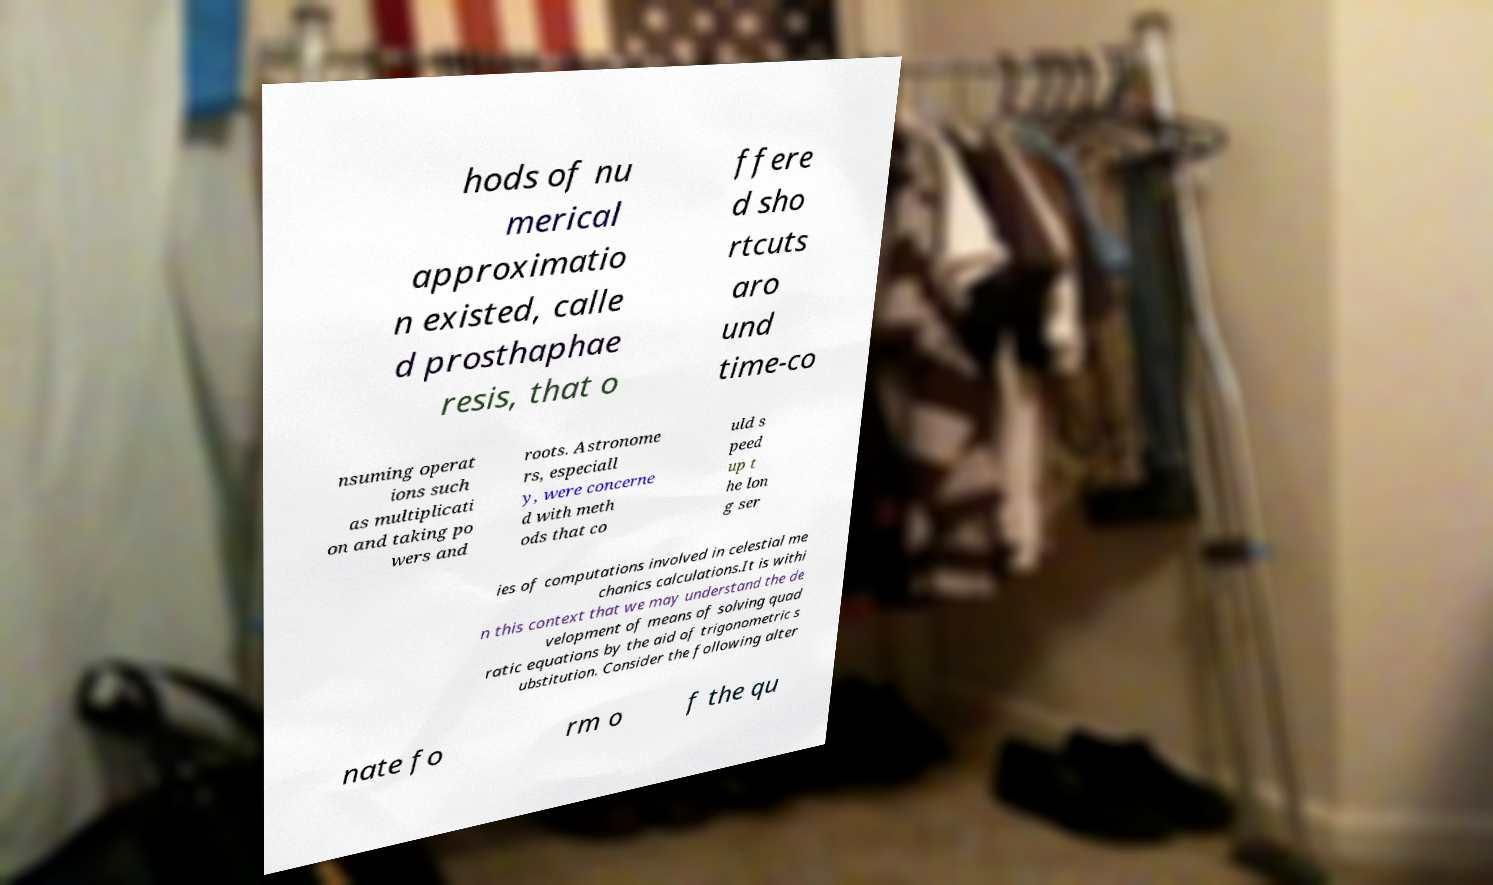Can you read and provide the text displayed in the image?This photo seems to have some interesting text. Can you extract and type it out for me? hods of nu merical approximatio n existed, calle d prosthaphae resis, that o ffere d sho rtcuts aro und time-co nsuming operat ions such as multiplicati on and taking po wers and roots. Astronome rs, especiall y, were concerne d with meth ods that co uld s peed up t he lon g ser ies of computations involved in celestial me chanics calculations.It is withi n this context that we may understand the de velopment of means of solving quad ratic equations by the aid of trigonometric s ubstitution. Consider the following alter nate fo rm o f the qu 